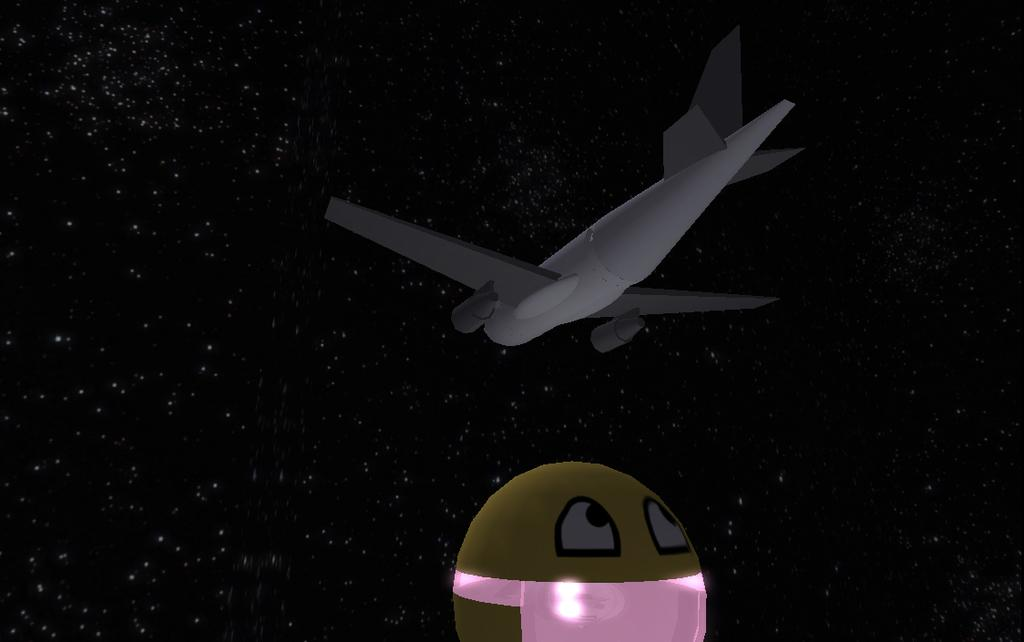What type of image is being described? The image is animated. What can be seen in the middle of the animated image? There is an aeroplane in the middle of the image. How would you describe the background of the image? The background of the image contains stars in the dark. What is located at the bottom of the image? There is a cartoon image at the bottom of the image. What type of canvas is being used to create the jail in the image? There is no jail present in the image, so it is not possible to determine what type of canvas might be used. 